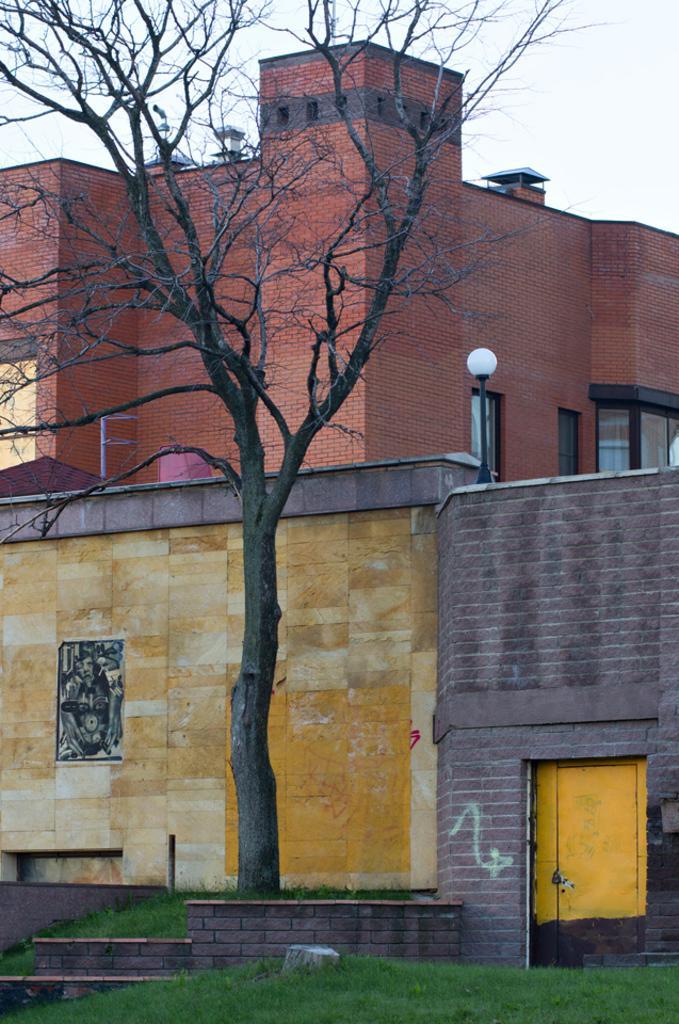In one or two sentences, can you explain what this image depicts? In this image I can see the dried tree. In the background I can see the light pole, few buildings in multi color and the sky is in white color. 